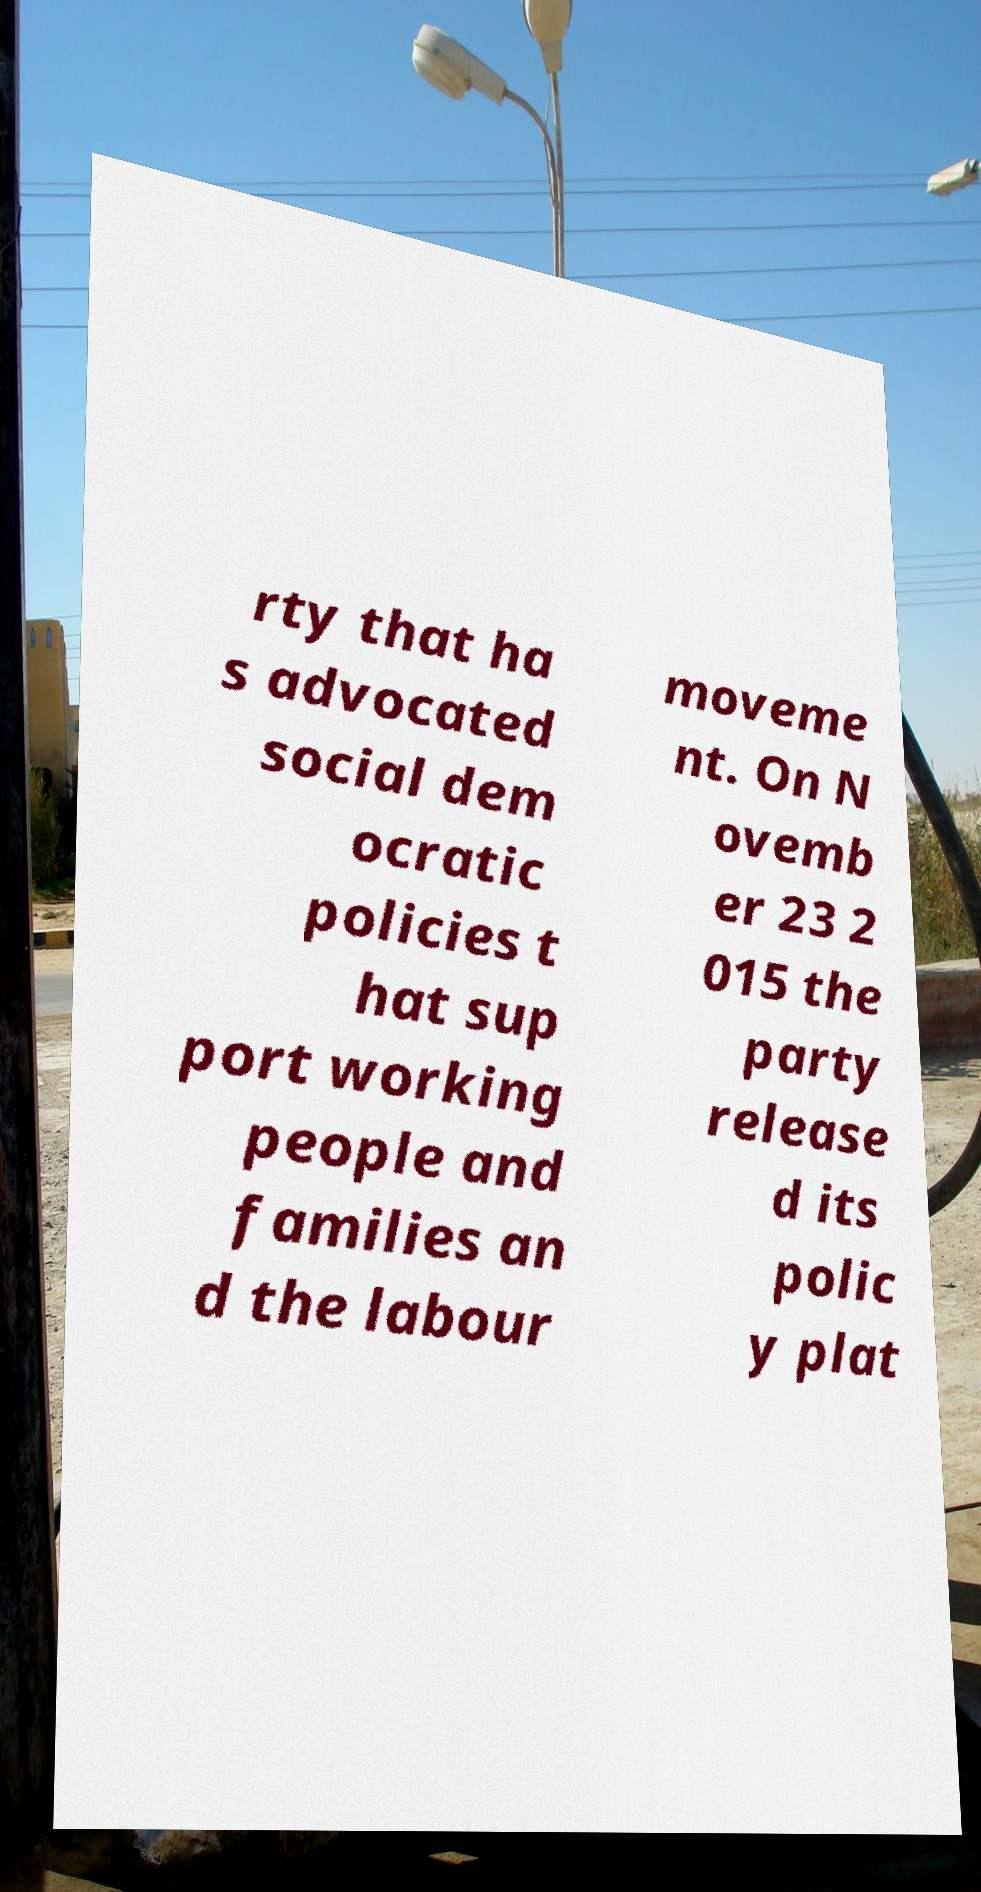Could you extract and type out the text from this image? rty that ha s advocated social dem ocratic policies t hat sup port working people and families an d the labour moveme nt. On N ovemb er 23 2 015 the party release d its polic y plat 